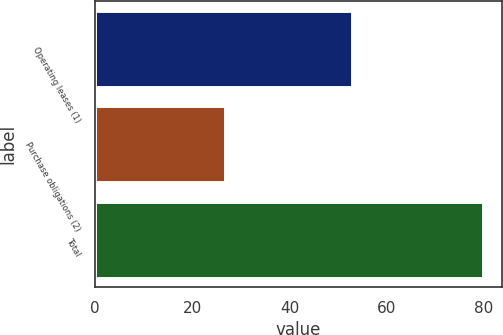Convert chart to OTSL. <chart><loc_0><loc_0><loc_500><loc_500><bar_chart><fcel>Operating leases (1)<fcel>Purchase obligations (2)<fcel>Total<nl><fcel>52.9<fcel>26.8<fcel>79.7<nl></chart> 